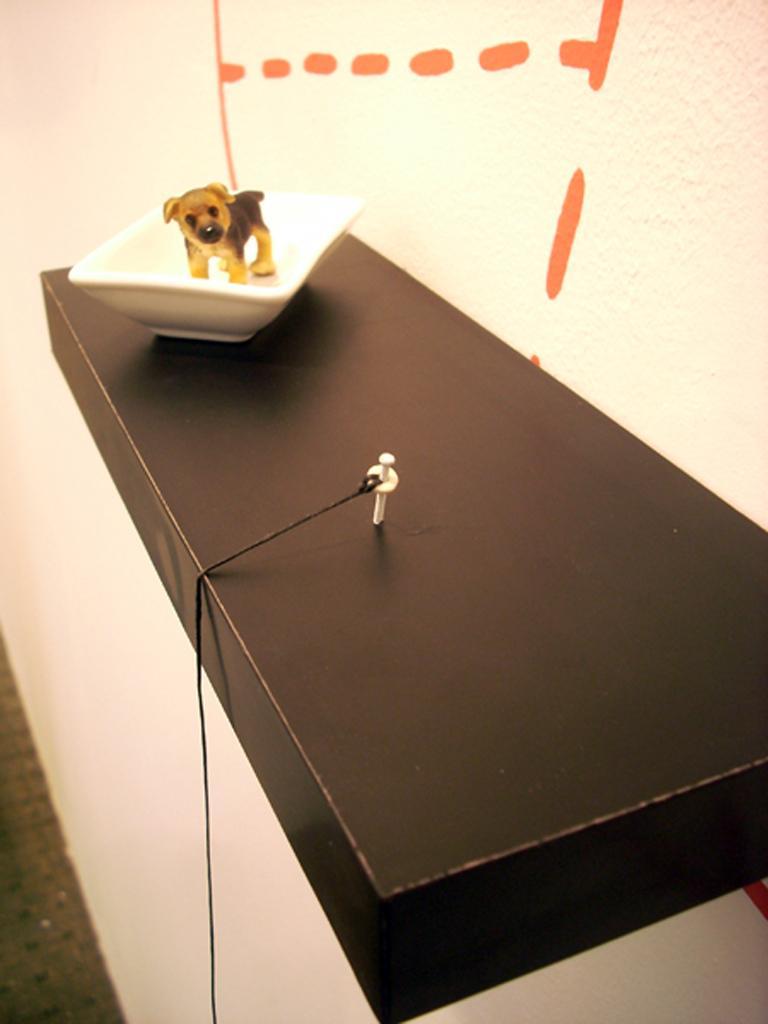In one or two sentences, can you explain what this image depicts? In this image I can see the toy animal in the bowl. The animal is in brown and black color and the bowl is in white color. It is on the black color surface. To the side I can see the rope and the nail. In the background I can see the wall. 